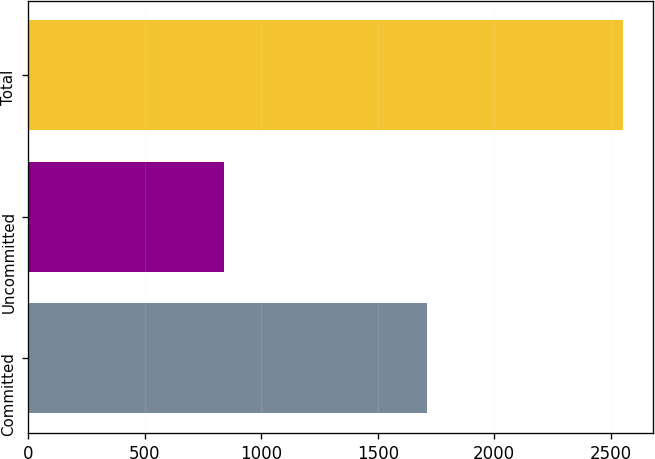<chart> <loc_0><loc_0><loc_500><loc_500><bar_chart><fcel>Committed<fcel>Uncommitted<fcel>Total<nl><fcel>1712<fcel>842<fcel>2554<nl></chart> 